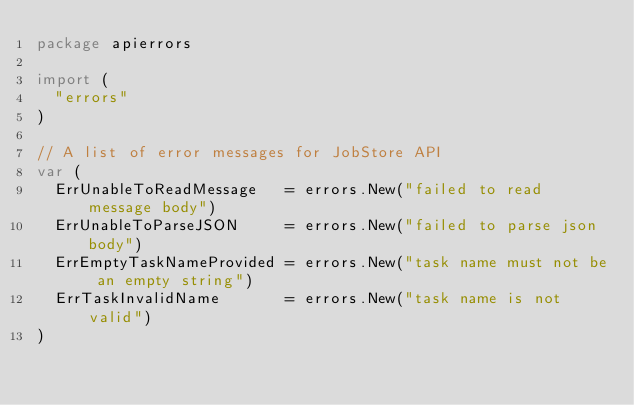<code> <loc_0><loc_0><loc_500><loc_500><_Go_>package apierrors

import (
	"errors"
)

// A list of error messages for JobStore API
var (
	ErrUnableToReadMessage   = errors.New("failed to read message body")
	ErrUnableToParseJSON     = errors.New("failed to parse json body")
	ErrEmptyTaskNameProvided = errors.New("task name must not be an empty string")
	ErrTaskInvalidName       = errors.New("task name is not valid")
)
</code> 